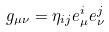<formula> <loc_0><loc_0><loc_500><loc_500>g _ { \mu \nu } = \eta _ { i j } e _ { \mu } ^ { i } e _ { \nu } ^ { j }</formula> 